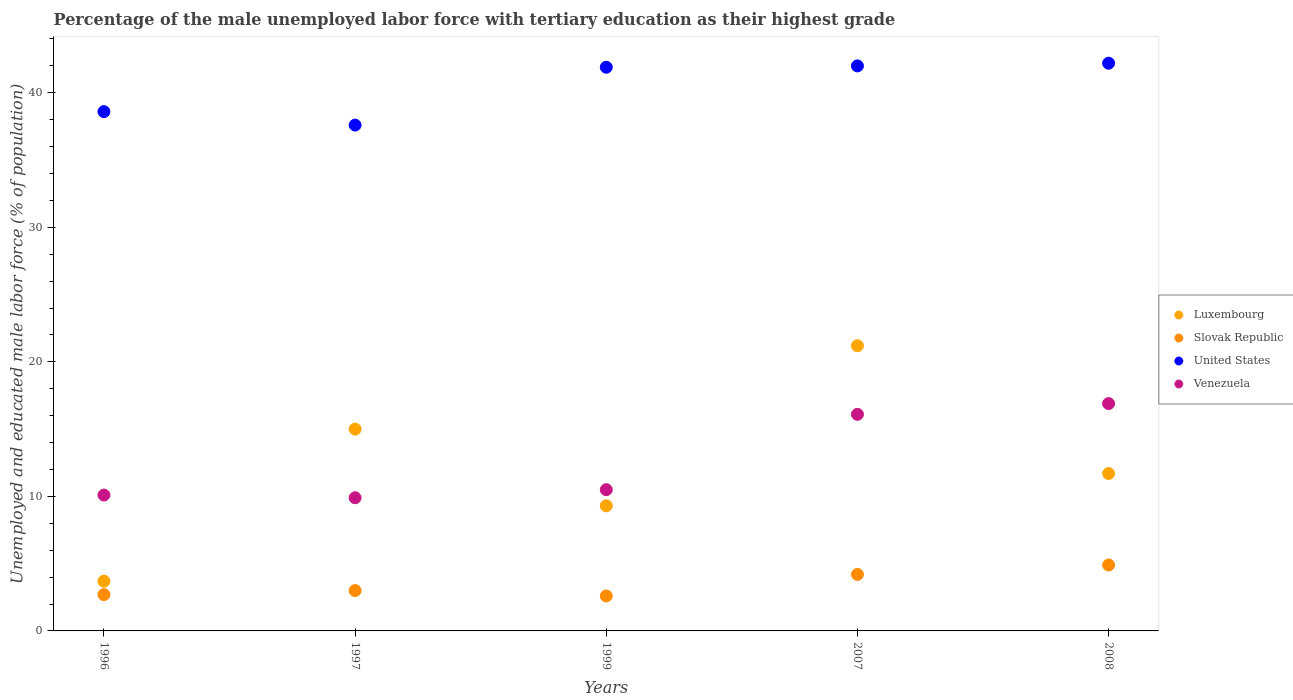Is the number of dotlines equal to the number of legend labels?
Offer a very short reply. Yes. What is the percentage of the unemployed male labor force with tertiary education in Venezuela in 2007?
Give a very brief answer. 16.1. Across all years, what is the maximum percentage of the unemployed male labor force with tertiary education in Slovak Republic?
Offer a terse response. 4.9. Across all years, what is the minimum percentage of the unemployed male labor force with tertiary education in Luxembourg?
Offer a terse response. 3.7. In which year was the percentage of the unemployed male labor force with tertiary education in Venezuela maximum?
Keep it short and to the point. 2008. What is the total percentage of the unemployed male labor force with tertiary education in United States in the graph?
Provide a short and direct response. 202.3. What is the difference between the percentage of the unemployed male labor force with tertiary education in Luxembourg in 2007 and that in 2008?
Give a very brief answer. 9.5. What is the difference between the percentage of the unemployed male labor force with tertiary education in Slovak Republic in 2008 and the percentage of the unemployed male labor force with tertiary education in United States in 2007?
Provide a short and direct response. -37.1. What is the average percentage of the unemployed male labor force with tertiary education in United States per year?
Ensure brevity in your answer.  40.46. In the year 1997, what is the difference between the percentage of the unemployed male labor force with tertiary education in United States and percentage of the unemployed male labor force with tertiary education in Venezuela?
Ensure brevity in your answer.  27.7. In how many years, is the percentage of the unemployed male labor force with tertiary education in Luxembourg greater than 30 %?
Provide a succinct answer. 0. What is the ratio of the percentage of the unemployed male labor force with tertiary education in Venezuela in 1996 to that in 2007?
Provide a succinct answer. 0.63. Is the percentage of the unemployed male labor force with tertiary education in Venezuela in 2007 less than that in 2008?
Offer a terse response. Yes. What is the difference between the highest and the second highest percentage of the unemployed male labor force with tertiary education in Slovak Republic?
Keep it short and to the point. 0.7. What is the difference between the highest and the lowest percentage of the unemployed male labor force with tertiary education in Luxembourg?
Your response must be concise. 17.5. In how many years, is the percentage of the unemployed male labor force with tertiary education in United States greater than the average percentage of the unemployed male labor force with tertiary education in United States taken over all years?
Ensure brevity in your answer.  3. Is it the case that in every year, the sum of the percentage of the unemployed male labor force with tertiary education in United States and percentage of the unemployed male labor force with tertiary education in Luxembourg  is greater than the sum of percentage of the unemployed male labor force with tertiary education in Venezuela and percentage of the unemployed male labor force with tertiary education in Slovak Republic?
Give a very brief answer. Yes. Is the percentage of the unemployed male labor force with tertiary education in Luxembourg strictly greater than the percentage of the unemployed male labor force with tertiary education in United States over the years?
Provide a short and direct response. No. How many years are there in the graph?
Make the answer very short. 5. Are the values on the major ticks of Y-axis written in scientific E-notation?
Provide a short and direct response. No. Does the graph contain any zero values?
Offer a very short reply. No. How many legend labels are there?
Make the answer very short. 4. How are the legend labels stacked?
Your answer should be very brief. Vertical. What is the title of the graph?
Keep it short and to the point. Percentage of the male unemployed labor force with tertiary education as their highest grade. What is the label or title of the Y-axis?
Keep it short and to the point. Unemployed and educated male labor force (% of population). What is the Unemployed and educated male labor force (% of population) of Luxembourg in 1996?
Offer a very short reply. 3.7. What is the Unemployed and educated male labor force (% of population) in Slovak Republic in 1996?
Offer a terse response. 2.7. What is the Unemployed and educated male labor force (% of population) of United States in 1996?
Offer a very short reply. 38.6. What is the Unemployed and educated male labor force (% of population) in Venezuela in 1996?
Offer a very short reply. 10.1. What is the Unemployed and educated male labor force (% of population) in United States in 1997?
Your answer should be very brief. 37.6. What is the Unemployed and educated male labor force (% of population) of Venezuela in 1997?
Provide a short and direct response. 9.9. What is the Unemployed and educated male labor force (% of population) in Luxembourg in 1999?
Ensure brevity in your answer.  9.3. What is the Unemployed and educated male labor force (% of population) of Slovak Republic in 1999?
Offer a terse response. 2.6. What is the Unemployed and educated male labor force (% of population) of United States in 1999?
Keep it short and to the point. 41.9. What is the Unemployed and educated male labor force (% of population) of Luxembourg in 2007?
Your response must be concise. 21.2. What is the Unemployed and educated male labor force (% of population) in Slovak Republic in 2007?
Your answer should be very brief. 4.2. What is the Unemployed and educated male labor force (% of population) in Venezuela in 2007?
Keep it short and to the point. 16.1. What is the Unemployed and educated male labor force (% of population) of Luxembourg in 2008?
Give a very brief answer. 11.7. What is the Unemployed and educated male labor force (% of population) in Slovak Republic in 2008?
Your answer should be very brief. 4.9. What is the Unemployed and educated male labor force (% of population) of United States in 2008?
Keep it short and to the point. 42.2. What is the Unemployed and educated male labor force (% of population) of Venezuela in 2008?
Give a very brief answer. 16.9. Across all years, what is the maximum Unemployed and educated male labor force (% of population) of Luxembourg?
Offer a very short reply. 21.2. Across all years, what is the maximum Unemployed and educated male labor force (% of population) of Slovak Republic?
Offer a terse response. 4.9. Across all years, what is the maximum Unemployed and educated male labor force (% of population) of United States?
Your response must be concise. 42.2. Across all years, what is the maximum Unemployed and educated male labor force (% of population) of Venezuela?
Provide a succinct answer. 16.9. Across all years, what is the minimum Unemployed and educated male labor force (% of population) in Luxembourg?
Provide a succinct answer. 3.7. Across all years, what is the minimum Unemployed and educated male labor force (% of population) in Slovak Republic?
Your answer should be compact. 2.6. Across all years, what is the minimum Unemployed and educated male labor force (% of population) in United States?
Ensure brevity in your answer.  37.6. Across all years, what is the minimum Unemployed and educated male labor force (% of population) of Venezuela?
Provide a succinct answer. 9.9. What is the total Unemployed and educated male labor force (% of population) in Luxembourg in the graph?
Offer a terse response. 60.9. What is the total Unemployed and educated male labor force (% of population) in United States in the graph?
Give a very brief answer. 202.3. What is the total Unemployed and educated male labor force (% of population) of Venezuela in the graph?
Give a very brief answer. 63.5. What is the difference between the Unemployed and educated male labor force (% of population) in Luxembourg in 1996 and that in 1997?
Provide a succinct answer. -11.3. What is the difference between the Unemployed and educated male labor force (% of population) of Slovak Republic in 1996 and that in 1999?
Keep it short and to the point. 0.1. What is the difference between the Unemployed and educated male labor force (% of population) of United States in 1996 and that in 1999?
Make the answer very short. -3.3. What is the difference between the Unemployed and educated male labor force (% of population) in Venezuela in 1996 and that in 1999?
Provide a short and direct response. -0.4. What is the difference between the Unemployed and educated male labor force (% of population) in Luxembourg in 1996 and that in 2007?
Ensure brevity in your answer.  -17.5. What is the difference between the Unemployed and educated male labor force (% of population) of Slovak Republic in 1996 and that in 2007?
Provide a succinct answer. -1.5. What is the difference between the Unemployed and educated male labor force (% of population) in United States in 1996 and that in 2007?
Your answer should be very brief. -3.4. What is the difference between the Unemployed and educated male labor force (% of population) in Venezuela in 1996 and that in 2007?
Your answer should be very brief. -6. What is the difference between the Unemployed and educated male labor force (% of population) in United States in 1996 and that in 2008?
Offer a very short reply. -3.6. What is the difference between the Unemployed and educated male labor force (% of population) in United States in 1997 and that in 1999?
Make the answer very short. -4.3. What is the difference between the Unemployed and educated male labor force (% of population) of Venezuela in 1997 and that in 1999?
Your answer should be very brief. -0.6. What is the difference between the Unemployed and educated male labor force (% of population) in Slovak Republic in 1997 and that in 2007?
Your answer should be compact. -1.2. What is the difference between the Unemployed and educated male labor force (% of population) in United States in 1997 and that in 2007?
Keep it short and to the point. -4.4. What is the difference between the Unemployed and educated male labor force (% of population) of Venezuela in 1997 and that in 2007?
Offer a very short reply. -6.2. What is the difference between the Unemployed and educated male labor force (% of population) in Luxembourg in 1997 and that in 2008?
Your answer should be very brief. 3.3. What is the difference between the Unemployed and educated male labor force (% of population) of Slovak Republic in 1997 and that in 2008?
Your answer should be very brief. -1.9. What is the difference between the Unemployed and educated male labor force (% of population) in Luxembourg in 1999 and that in 2007?
Ensure brevity in your answer.  -11.9. What is the difference between the Unemployed and educated male labor force (% of population) of Slovak Republic in 1999 and that in 2007?
Ensure brevity in your answer.  -1.6. What is the difference between the Unemployed and educated male labor force (% of population) in Venezuela in 1999 and that in 2007?
Offer a very short reply. -5.6. What is the difference between the Unemployed and educated male labor force (% of population) of Slovak Republic in 1999 and that in 2008?
Offer a very short reply. -2.3. What is the difference between the Unemployed and educated male labor force (% of population) of Luxembourg in 2007 and that in 2008?
Offer a very short reply. 9.5. What is the difference between the Unemployed and educated male labor force (% of population) of Luxembourg in 1996 and the Unemployed and educated male labor force (% of population) of United States in 1997?
Provide a succinct answer. -33.9. What is the difference between the Unemployed and educated male labor force (% of population) in Luxembourg in 1996 and the Unemployed and educated male labor force (% of population) in Venezuela in 1997?
Provide a short and direct response. -6.2. What is the difference between the Unemployed and educated male labor force (% of population) in Slovak Republic in 1996 and the Unemployed and educated male labor force (% of population) in United States in 1997?
Give a very brief answer. -34.9. What is the difference between the Unemployed and educated male labor force (% of population) of United States in 1996 and the Unemployed and educated male labor force (% of population) of Venezuela in 1997?
Keep it short and to the point. 28.7. What is the difference between the Unemployed and educated male labor force (% of population) of Luxembourg in 1996 and the Unemployed and educated male labor force (% of population) of United States in 1999?
Provide a succinct answer. -38.2. What is the difference between the Unemployed and educated male labor force (% of population) in Luxembourg in 1996 and the Unemployed and educated male labor force (% of population) in Venezuela in 1999?
Your answer should be compact. -6.8. What is the difference between the Unemployed and educated male labor force (% of population) of Slovak Republic in 1996 and the Unemployed and educated male labor force (% of population) of United States in 1999?
Make the answer very short. -39.2. What is the difference between the Unemployed and educated male labor force (% of population) of United States in 1996 and the Unemployed and educated male labor force (% of population) of Venezuela in 1999?
Give a very brief answer. 28.1. What is the difference between the Unemployed and educated male labor force (% of population) of Luxembourg in 1996 and the Unemployed and educated male labor force (% of population) of Slovak Republic in 2007?
Keep it short and to the point. -0.5. What is the difference between the Unemployed and educated male labor force (% of population) in Luxembourg in 1996 and the Unemployed and educated male labor force (% of population) in United States in 2007?
Offer a very short reply. -38.3. What is the difference between the Unemployed and educated male labor force (% of population) in Slovak Republic in 1996 and the Unemployed and educated male labor force (% of population) in United States in 2007?
Offer a very short reply. -39.3. What is the difference between the Unemployed and educated male labor force (% of population) in Slovak Republic in 1996 and the Unemployed and educated male labor force (% of population) in Venezuela in 2007?
Keep it short and to the point. -13.4. What is the difference between the Unemployed and educated male labor force (% of population) of United States in 1996 and the Unemployed and educated male labor force (% of population) of Venezuela in 2007?
Your answer should be compact. 22.5. What is the difference between the Unemployed and educated male labor force (% of population) in Luxembourg in 1996 and the Unemployed and educated male labor force (% of population) in United States in 2008?
Make the answer very short. -38.5. What is the difference between the Unemployed and educated male labor force (% of population) of Slovak Republic in 1996 and the Unemployed and educated male labor force (% of population) of United States in 2008?
Give a very brief answer. -39.5. What is the difference between the Unemployed and educated male labor force (% of population) of United States in 1996 and the Unemployed and educated male labor force (% of population) of Venezuela in 2008?
Ensure brevity in your answer.  21.7. What is the difference between the Unemployed and educated male labor force (% of population) in Luxembourg in 1997 and the Unemployed and educated male labor force (% of population) in United States in 1999?
Your answer should be very brief. -26.9. What is the difference between the Unemployed and educated male labor force (% of population) of Luxembourg in 1997 and the Unemployed and educated male labor force (% of population) of Venezuela in 1999?
Offer a very short reply. 4.5. What is the difference between the Unemployed and educated male labor force (% of population) in Slovak Republic in 1997 and the Unemployed and educated male labor force (% of population) in United States in 1999?
Ensure brevity in your answer.  -38.9. What is the difference between the Unemployed and educated male labor force (% of population) of Slovak Republic in 1997 and the Unemployed and educated male labor force (% of population) of Venezuela in 1999?
Offer a terse response. -7.5. What is the difference between the Unemployed and educated male labor force (% of population) in United States in 1997 and the Unemployed and educated male labor force (% of population) in Venezuela in 1999?
Offer a terse response. 27.1. What is the difference between the Unemployed and educated male labor force (% of population) of Luxembourg in 1997 and the Unemployed and educated male labor force (% of population) of Slovak Republic in 2007?
Give a very brief answer. 10.8. What is the difference between the Unemployed and educated male labor force (% of population) in Luxembourg in 1997 and the Unemployed and educated male labor force (% of population) in United States in 2007?
Provide a short and direct response. -27. What is the difference between the Unemployed and educated male labor force (% of population) of Slovak Republic in 1997 and the Unemployed and educated male labor force (% of population) of United States in 2007?
Offer a terse response. -39. What is the difference between the Unemployed and educated male labor force (% of population) of Slovak Republic in 1997 and the Unemployed and educated male labor force (% of population) of Venezuela in 2007?
Ensure brevity in your answer.  -13.1. What is the difference between the Unemployed and educated male labor force (% of population) in Luxembourg in 1997 and the Unemployed and educated male labor force (% of population) in United States in 2008?
Provide a short and direct response. -27.2. What is the difference between the Unemployed and educated male labor force (% of population) of Luxembourg in 1997 and the Unemployed and educated male labor force (% of population) of Venezuela in 2008?
Make the answer very short. -1.9. What is the difference between the Unemployed and educated male labor force (% of population) of Slovak Republic in 1997 and the Unemployed and educated male labor force (% of population) of United States in 2008?
Provide a succinct answer. -39.2. What is the difference between the Unemployed and educated male labor force (% of population) in United States in 1997 and the Unemployed and educated male labor force (% of population) in Venezuela in 2008?
Ensure brevity in your answer.  20.7. What is the difference between the Unemployed and educated male labor force (% of population) in Luxembourg in 1999 and the Unemployed and educated male labor force (% of population) in United States in 2007?
Give a very brief answer. -32.7. What is the difference between the Unemployed and educated male labor force (% of population) of Luxembourg in 1999 and the Unemployed and educated male labor force (% of population) of Venezuela in 2007?
Provide a short and direct response. -6.8. What is the difference between the Unemployed and educated male labor force (% of population) in Slovak Republic in 1999 and the Unemployed and educated male labor force (% of population) in United States in 2007?
Your answer should be very brief. -39.4. What is the difference between the Unemployed and educated male labor force (% of population) in Slovak Republic in 1999 and the Unemployed and educated male labor force (% of population) in Venezuela in 2007?
Keep it short and to the point. -13.5. What is the difference between the Unemployed and educated male labor force (% of population) of United States in 1999 and the Unemployed and educated male labor force (% of population) of Venezuela in 2007?
Keep it short and to the point. 25.8. What is the difference between the Unemployed and educated male labor force (% of population) in Luxembourg in 1999 and the Unemployed and educated male labor force (% of population) in Slovak Republic in 2008?
Keep it short and to the point. 4.4. What is the difference between the Unemployed and educated male labor force (% of population) of Luxembourg in 1999 and the Unemployed and educated male labor force (% of population) of United States in 2008?
Offer a very short reply. -32.9. What is the difference between the Unemployed and educated male labor force (% of population) of Slovak Republic in 1999 and the Unemployed and educated male labor force (% of population) of United States in 2008?
Provide a succinct answer. -39.6. What is the difference between the Unemployed and educated male labor force (% of population) in Slovak Republic in 1999 and the Unemployed and educated male labor force (% of population) in Venezuela in 2008?
Your response must be concise. -14.3. What is the difference between the Unemployed and educated male labor force (% of population) in Luxembourg in 2007 and the Unemployed and educated male labor force (% of population) in Venezuela in 2008?
Keep it short and to the point. 4.3. What is the difference between the Unemployed and educated male labor force (% of population) in Slovak Republic in 2007 and the Unemployed and educated male labor force (% of population) in United States in 2008?
Provide a short and direct response. -38. What is the difference between the Unemployed and educated male labor force (% of population) of Slovak Republic in 2007 and the Unemployed and educated male labor force (% of population) of Venezuela in 2008?
Give a very brief answer. -12.7. What is the difference between the Unemployed and educated male labor force (% of population) in United States in 2007 and the Unemployed and educated male labor force (% of population) in Venezuela in 2008?
Offer a very short reply. 25.1. What is the average Unemployed and educated male labor force (% of population) of Luxembourg per year?
Offer a terse response. 12.18. What is the average Unemployed and educated male labor force (% of population) in Slovak Republic per year?
Keep it short and to the point. 3.48. What is the average Unemployed and educated male labor force (% of population) in United States per year?
Provide a succinct answer. 40.46. What is the average Unemployed and educated male labor force (% of population) in Venezuela per year?
Your answer should be compact. 12.7. In the year 1996, what is the difference between the Unemployed and educated male labor force (% of population) in Luxembourg and Unemployed and educated male labor force (% of population) in Slovak Republic?
Ensure brevity in your answer.  1. In the year 1996, what is the difference between the Unemployed and educated male labor force (% of population) in Luxembourg and Unemployed and educated male labor force (% of population) in United States?
Offer a very short reply. -34.9. In the year 1996, what is the difference between the Unemployed and educated male labor force (% of population) of Slovak Republic and Unemployed and educated male labor force (% of population) of United States?
Your answer should be very brief. -35.9. In the year 1996, what is the difference between the Unemployed and educated male labor force (% of population) of Slovak Republic and Unemployed and educated male labor force (% of population) of Venezuela?
Provide a short and direct response. -7.4. In the year 1996, what is the difference between the Unemployed and educated male labor force (% of population) in United States and Unemployed and educated male labor force (% of population) in Venezuela?
Provide a short and direct response. 28.5. In the year 1997, what is the difference between the Unemployed and educated male labor force (% of population) of Luxembourg and Unemployed and educated male labor force (% of population) of Slovak Republic?
Keep it short and to the point. 12. In the year 1997, what is the difference between the Unemployed and educated male labor force (% of population) in Luxembourg and Unemployed and educated male labor force (% of population) in United States?
Keep it short and to the point. -22.6. In the year 1997, what is the difference between the Unemployed and educated male labor force (% of population) in Slovak Republic and Unemployed and educated male labor force (% of population) in United States?
Offer a very short reply. -34.6. In the year 1997, what is the difference between the Unemployed and educated male labor force (% of population) in Slovak Republic and Unemployed and educated male labor force (% of population) in Venezuela?
Your answer should be very brief. -6.9. In the year 1997, what is the difference between the Unemployed and educated male labor force (% of population) in United States and Unemployed and educated male labor force (% of population) in Venezuela?
Give a very brief answer. 27.7. In the year 1999, what is the difference between the Unemployed and educated male labor force (% of population) of Luxembourg and Unemployed and educated male labor force (% of population) of Slovak Republic?
Your answer should be compact. 6.7. In the year 1999, what is the difference between the Unemployed and educated male labor force (% of population) of Luxembourg and Unemployed and educated male labor force (% of population) of United States?
Provide a short and direct response. -32.6. In the year 1999, what is the difference between the Unemployed and educated male labor force (% of population) of Luxembourg and Unemployed and educated male labor force (% of population) of Venezuela?
Your response must be concise. -1.2. In the year 1999, what is the difference between the Unemployed and educated male labor force (% of population) of Slovak Republic and Unemployed and educated male labor force (% of population) of United States?
Ensure brevity in your answer.  -39.3. In the year 1999, what is the difference between the Unemployed and educated male labor force (% of population) of Slovak Republic and Unemployed and educated male labor force (% of population) of Venezuela?
Give a very brief answer. -7.9. In the year 1999, what is the difference between the Unemployed and educated male labor force (% of population) in United States and Unemployed and educated male labor force (% of population) in Venezuela?
Make the answer very short. 31.4. In the year 2007, what is the difference between the Unemployed and educated male labor force (% of population) in Luxembourg and Unemployed and educated male labor force (% of population) in United States?
Ensure brevity in your answer.  -20.8. In the year 2007, what is the difference between the Unemployed and educated male labor force (% of population) in Slovak Republic and Unemployed and educated male labor force (% of population) in United States?
Give a very brief answer. -37.8. In the year 2007, what is the difference between the Unemployed and educated male labor force (% of population) of Slovak Republic and Unemployed and educated male labor force (% of population) of Venezuela?
Your answer should be compact. -11.9. In the year 2007, what is the difference between the Unemployed and educated male labor force (% of population) in United States and Unemployed and educated male labor force (% of population) in Venezuela?
Ensure brevity in your answer.  25.9. In the year 2008, what is the difference between the Unemployed and educated male labor force (% of population) of Luxembourg and Unemployed and educated male labor force (% of population) of Slovak Republic?
Ensure brevity in your answer.  6.8. In the year 2008, what is the difference between the Unemployed and educated male labor force (% of population) in Luxembourg and Unemployed and educated male labor force (% of population) in United States?
Your answer should be compact. -30.5. In the year 2008, what is the difference between the Unemployed and educated male labor force (% of population) of Luxembourg and Unemployed and educated male labor force (% of population) of Venezuela?
Provide a short and direct response. -5.2. In the year 2008, what is the difference between the Unemployed and educated male labor force (% of population) of Slovak Republic and Unemployed and educated male labor force (% of population) of United States?
Give a very brief answer. -37.3. In the year 2008, what is the difference between the Unemployed and educated male labor force (% of population) in Slovak Republic and Unemployed and educated male labor force (% of population) in Venezuela?
Offer a terse response. -12. In the year 2008, what is the difference between the Unemployed and educated male labor force (% of population) in United States and Unemployed and educated male labor force (% of population) in Venezuela?
Provide a short and direct response. 25.3. What is the ratio of the Unemployed and educated male labor force (% of population) in Luxembourg in 1996 to that in 1997?
Offer a terse response. 0.25. What is the ratio of the Unemployed and educated male labor force (% of population) of Slovak Republic in 1996 to that in 1997?
Provide a succinct answer. 0.9. What is the ratio of the Unemployed and educated male labor force (% of population) in United States in 1996 to that in 1997?
Offer a terse response. 1.03. What is the ratio of the Unemployed and educated male labor force (% of population) in Venezuela in 1996 to that in 1997?
Provide a succinct answer. 1.02. What is the ratio of the Unemployed and educated male labor force (% of population) of Luxembourg in 1996 to that in 1999?
Keep it short and to the point. 0.4. What is the ratio of the Unemployed and educated male labor force (% of population) of Slovak Republic in 1996 to that in 1999?
Your answer should be compact. 1.04. What is the ratio of the Unemployed and educated male labor force (% of population) in United States in 1996 to that in 1999?
Your response must be concise. 0.92. What is the ratio of the Unemployed and educated male labor force (% of population) of Venezuela in 1996 to that in 1999?
Offer a terse response. 0.96. What is the ratio of the Unemployed and educated male labor force (% of population) of Luxembourg in 1996 to that in 2007?
Offer a very short reply. 0.17. What is the ratio of the Unemployed and educated male labor force (% of population) in Slovak Republic in 1996 to that in 2007?
Offer a very short reply. 0.64. What is the ratio of the Unemployed and educated male labor force (% of population) of United States in 1996 to that in 2007?
Provide a short and direct response. 0.92. What is the ratio of the Unemployed and educated male labor force (% of population) of Venezuela in 1996 to that in 2007?
Your response must be concise. 0.63. What is the ratio of the Unemployed and educated male labor force (% of population) in Luxembourg in 1996 to that in 2008?
Provide a succinct answer. 0.32. What is the ratio of the Unemployed and educated male labor force (% of population) in Slovak Republic in 1996 to that in 2008?
Provide a succinct answer. 0.55. What is the ratio of the Unemployed and educated male labor force (% of population) of United States in 1996 to that in 2008?
Give a very brief answer. 0.91. What is the ratio of the Unemployed and educated male labor force (% of population) in Venezuela in 1996 to that in 2008?
Ensure brevity in your answer.  0.6. What is the ratio of the Unemployed and educated male labor force (% of population) in Luxembourg in 1997 to that in 1999?
Give a very brief answer. 1.61. What is the ratio of the Unemployed and educated male labor force (% of population) of Slovak Republic in 1997 to that in 1999?
Your answer should be compact. 1.15. What is the ratio of the Unemployed and educated male labor force (% of population) in United States in 1997 to that in 1999?
Offer a very short reply. 0.9. What is the ratio of the Unemployed and educated male labor force (% of population) in Venezuela in 1997 to that in 1999?
Provide a succinct answer. 0.94. What is the ratio of the Unemployed and educated male labor force (% of population) in Luxembourg in 1997 to that in 2007?
Your response must be concise. 0.71. What is the ratio of the Unemployed and educated male labor force (% of population) of Slovak Republic in 1997 to that in 2007?
Give a very brief answer. 0.71. What is the ratio of the Unemployed and educated male labor force (% of population) of United States in 1997 to that in 2007?
Your answer should be compact. 0.9. What is the ratio of the Unemployed and educated male labor force (% of population) of Venezuela in 1997 to that in 2007?
Your response must be concise. 0.61. What is the ratio of the Unemployed and educated male labor force (% of population) in Luxembourg in 1997 to that in 2008?
Offer a very short reply. 1.28. What is the ratio of the Unemployed and educated male labor force (% of population) in Slovak Republic in 1997 to that in 2008?
Offer a very short reply. 0.61. What is the ratio of the Unemployed and educated male labor force (% of population) in United States in 1997 to that in 2008?
Make the answer very short. 0.89. What is the ratio of the Unemployed and educated male labor force (% of population) of Venezuela in 1997 to that in 2008?
Give a very brief answer. 0.59. What is the ratio of the Unemployed and educated male labor force (% of population) of Luxembourg in 1999 to that in 2007?
Keep it short and to the point. 0.44. What is the ratio of the Unemployed and educated male labor force (% of population) of Slovak Republic in 1999 to that in 2007?
Your answer should be very brief. 0.62. What is the ratio of the Unemployed and educated male labor force (% of population) of Venezuela in 1999 to that in 2007?
Provide a short and direct response. 0.65. What is the ratio of the Unemployed and educated male labor force (% of population) in Luxembourg in 1999 to that in 2008?
Ensure brevity in your answer.  0.79. What is the ratio of the Unemployed and educated male labor force (% of population) in Slovak Republic in 1999 to that in 2008?
Offer a very short reply. 0.53. What is the ratio of the Unemployed and educated male labor force (% of population) in Venezuela in 1999 to that in 2008?
Your response must be concise. 0.62. What is the ratio of the Unemployed and educated male labor force (% of population) of Luxembourg in 2007 to that in 2008?
Give a very brief answer. 1.81. What is the ratio of the Unemployed and educated male labor force (% of population) in United States in 2007 to that in 2008?
Offer a very short reply. 1. What is the ratio of the Unemployed and educated male labor force (% of population) in Venezuela in 2007 to that in 2008?
Make the answer very short. 0.95. What is the difference between the highest and the second highest Unemployed and educated male labor force (% of population) in United States?
Give a very brief answer. 0.2. What is the difference between the highest and the lowest Unemployed and educated male labor force (% of population) of Luxembourg?
Your answer should be very brief. 17.5. What is the difference between the highest and the lowest Unemployed and educated male labor force (% of population) in Slovak Republic?
Offer a terse response. 2.3. What is the difference between the highest and the lowest Unemployed and educated male labor force (% of population) of United States?
Ensure brevity in your answer.  4.6. What is the difference between the highest and the lowest Unemployed and educated male labor force (% of population) of Venezuela?
Make the answer very short. 7. 